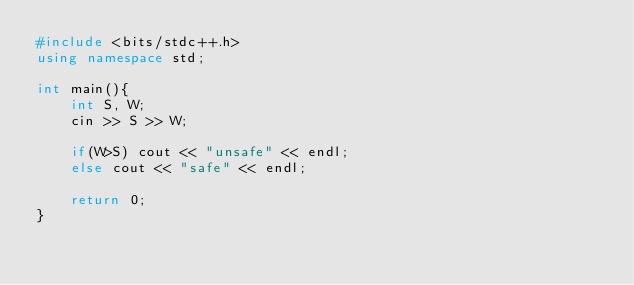<code> <loc_0><loc_0><loc_500><loc_500><_C++_>#include <bits/stdc++.h>
using namespace std;
 
int main(){
    int S, W;
    cin >> S >> W;

    if(W>S) cout << "unsafe" << endl;
    else cout << "safe" << endl;
    
    return 0;
}
</code> 